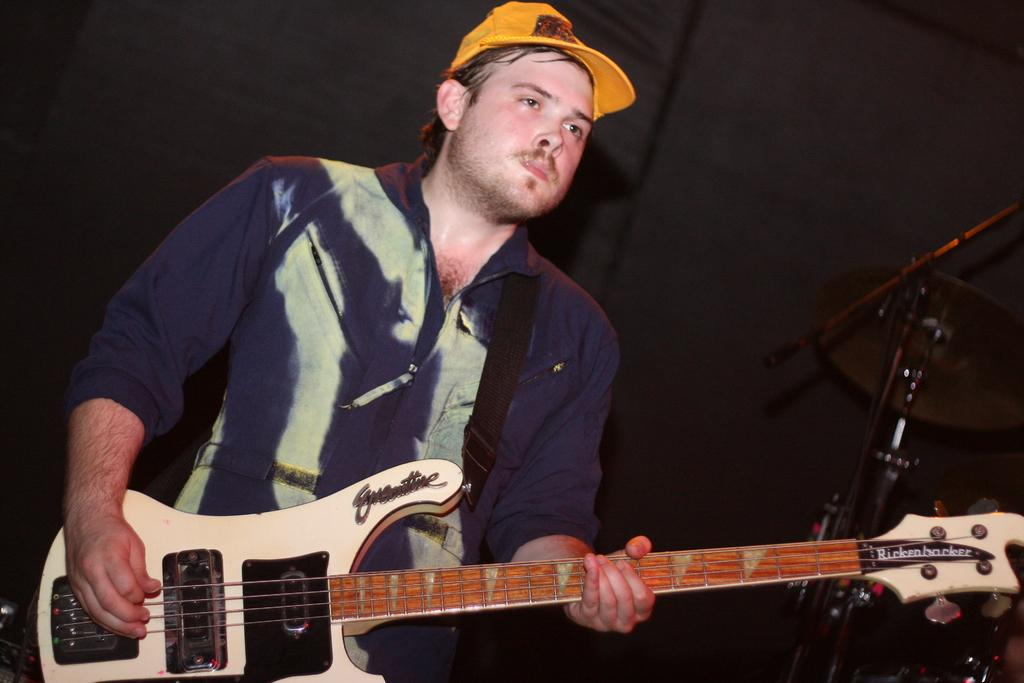What is the main subject of the image? There is a person in the image. What is the person doing in the image? The person is standing and playing a guitar. What type of clothing is the person wearing in the image? The person is wearing a cap. What type of twig is the person holding in the image? There is no twig present in the image; the person is playing a guitar. What type of nut is the person eating while playing the guitar in the image? There is no nut present in the image; the person is playing a guitar and wearing a cap. 